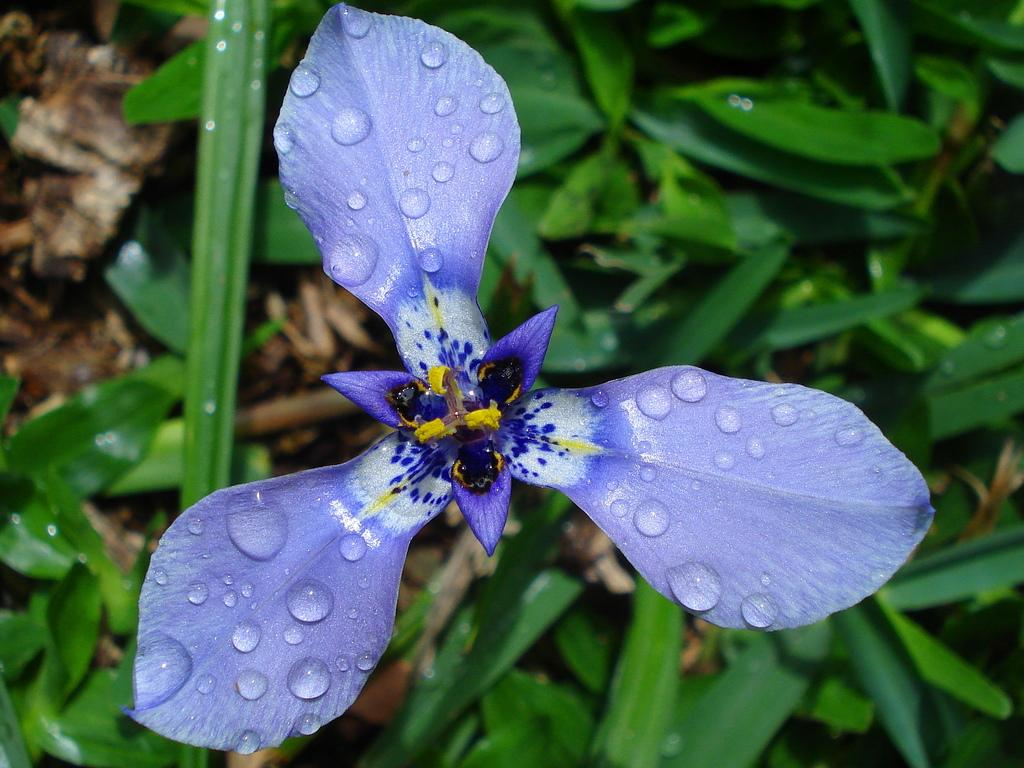What is the main subject in the foreground of the picture? There is a violet color flower in the foreground of the picture. What can be observed on the flower's petals? The flower's petals have water droplets on them. What can be seen in the background of the picture? There are plants and dry leaves in the background of the picture. What grade did the flower receive in the image? There is no indication of a grade in the image, as it is a photograph of a flower with water droplets on its petals. 